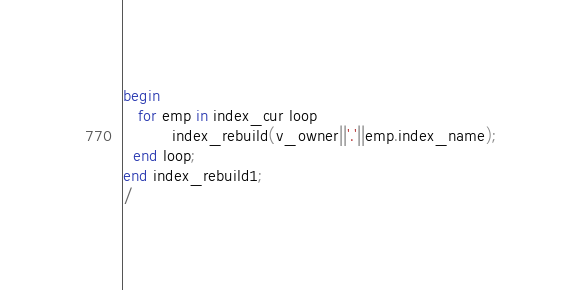<code> <loc_0><loc_0><loc_500><loc_500><_SQL_>begin
   for emp in index_cur loop
          index_rebuild(v_owner||'.'||emp.index_name);
  end loop; 	  
end index_rebuild1; 
/
</code> 